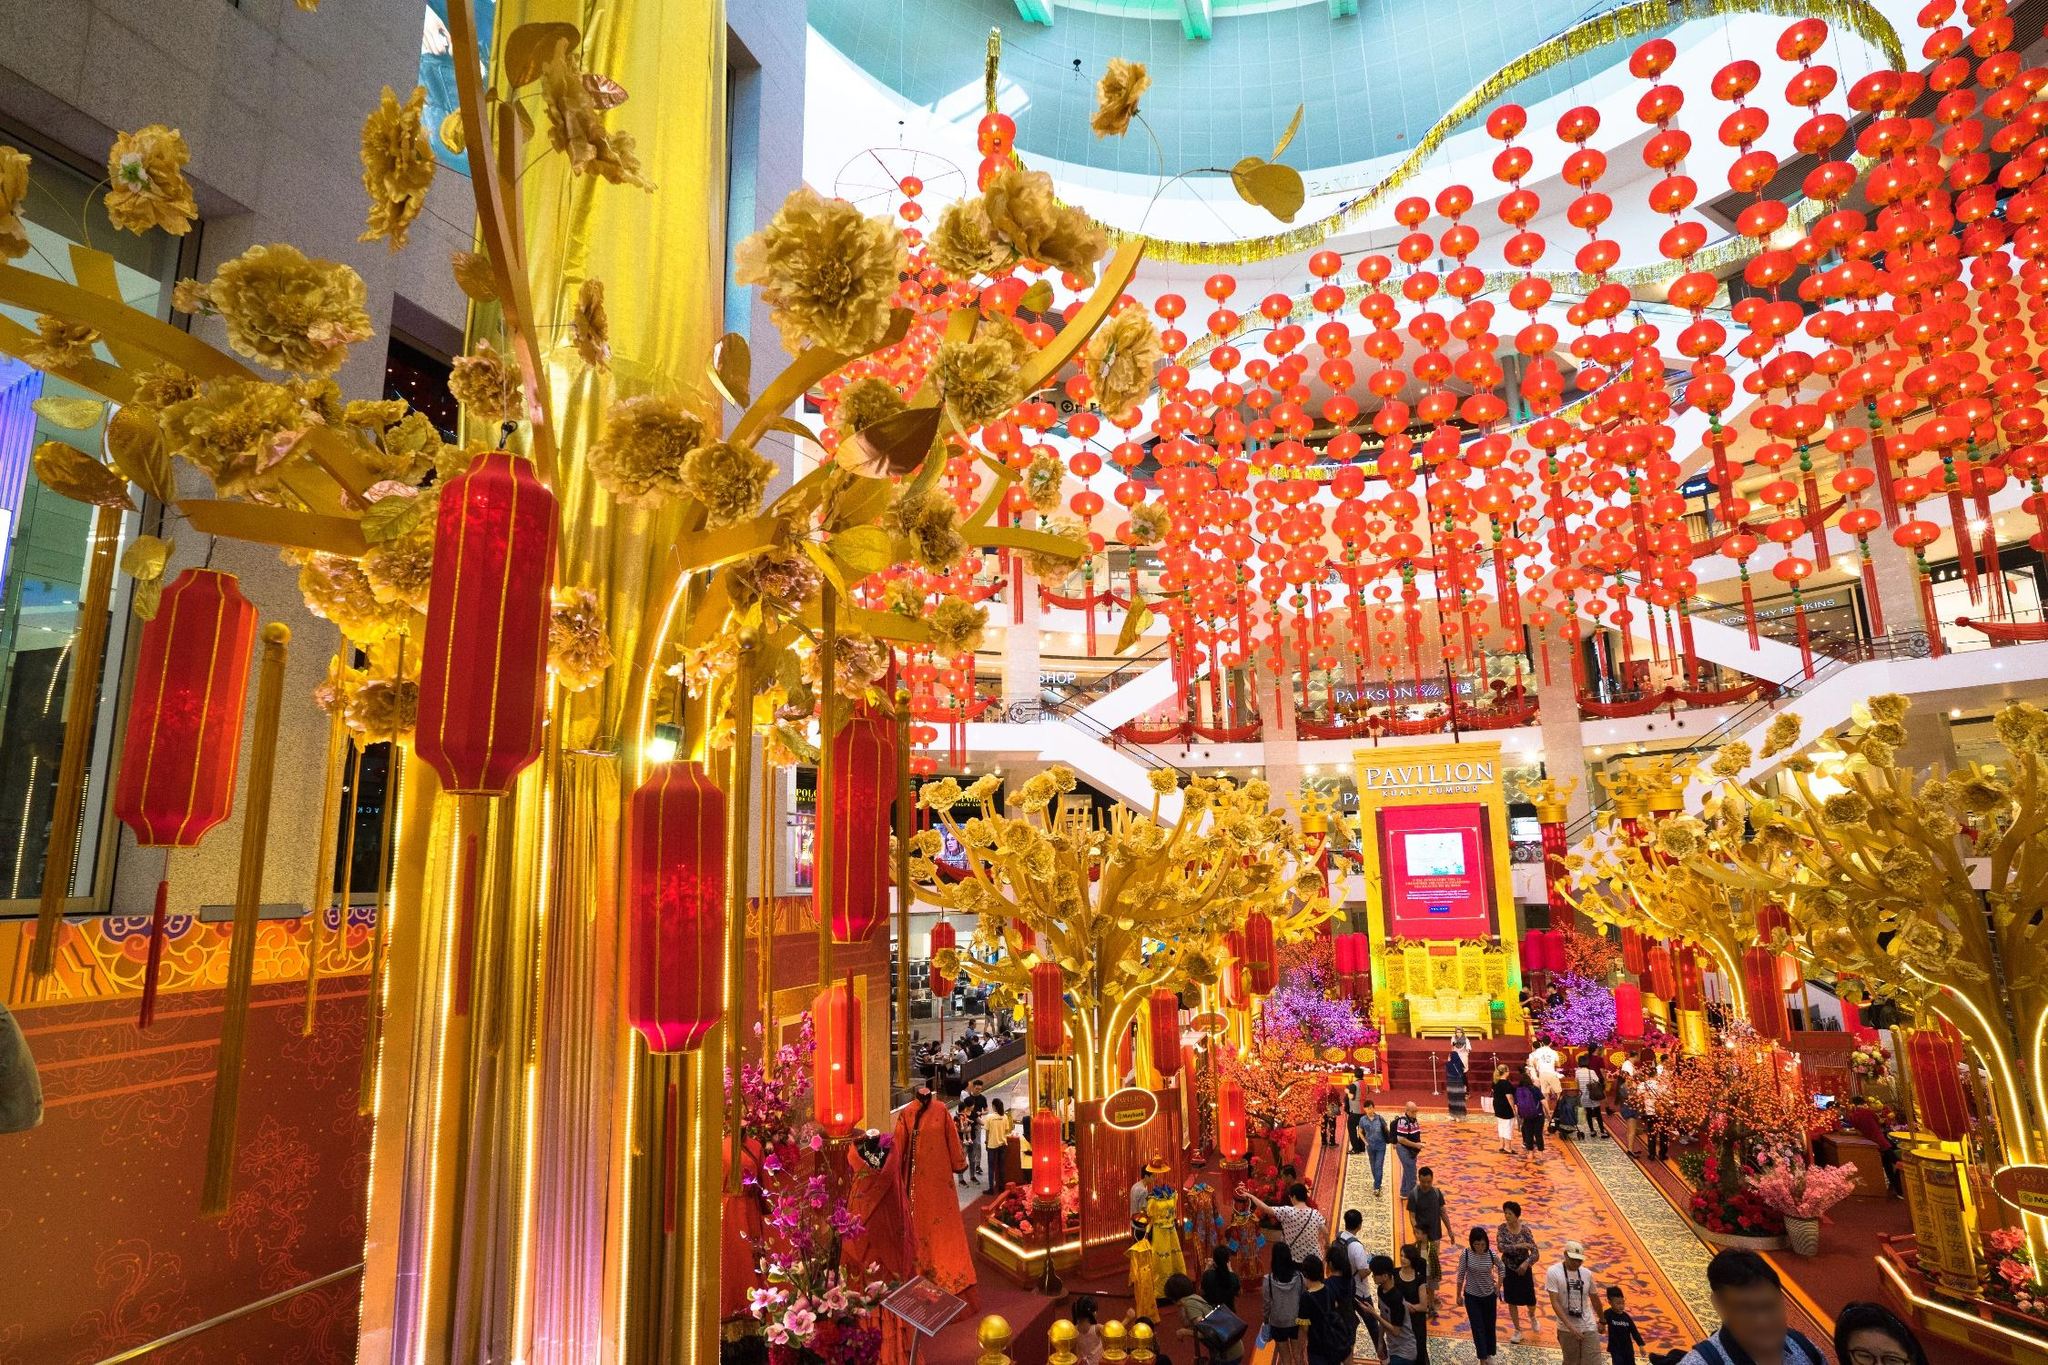How do such decorations impact the shopping experience? Decorations like these significantly enhance the shopping experience by creating an engaging, visually stimulating environment. It transforms the mall into a destination, not just for shopping but for enjoying the celebration and cultural expression, which may encourage longer visits and increased sales during the festival season. Are there specific activities or performances held in these decorated areas? Yes, malls often host special activities and performances during festival seasons to attract visitors. These might include traditional dance performances, live music, and interactive cultural exhibitions, which all add to the rich, immersive experience of the festival within a commercial space. 